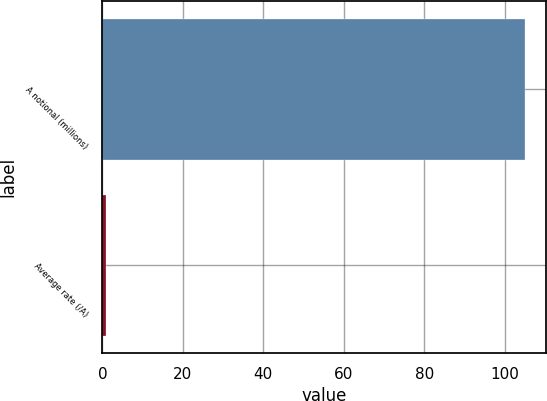Convert chart to OTSL. <chart><loc_0><loc_0><loc_500><loc_500><bar_chart><fcel>A notional (millions)<fcel>Average rate (/A)<nl><fcel>105<fcel>0.93<nl></chart> 